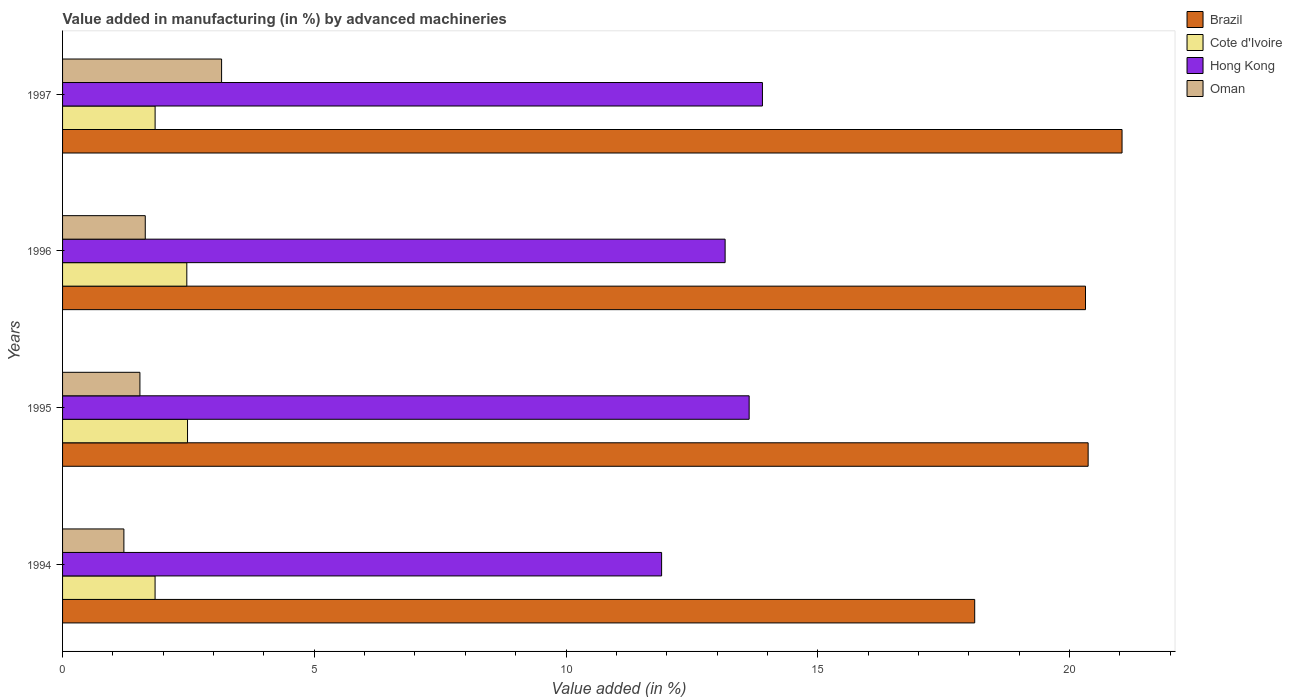How many different coloured bars are there?
Provide a short and direct response. 4. How many groups of bars are there?
Make the answer very short. 4. Are the number of bars on each tick of the Y-axis equal?
Your answer should be very brief. Yes. How many bars are there on the 3rd tick from the top?
Your answer should be compact. 4. In how many cases, is the number of bars for a given year not equal to the number of legend labels?
Provide a short and direct response. 0. What is the percentage of value added in manufacturing by advanced machineries in Oman in 1995?
Keep it short and to the point. 1.54. Across all years, what is the maximum percentage of value added in manufacturing by advanced machineries in Brazil?
Provide a succinct answer. 21.04. Across all years, what is the minimum percentage of value added in manufacturing by advanced machineries in Hong Kong?
Keep it short and to the point. 11.9. In which year was the percentage of value added in manufacturing by advanced machineries in Hong Kong maximum?
Your answer should be compact. 1997. What is the total percentage of value added in manufacturing by advanced machineries in Hong Kong in the graph?
Offer a very short reply. 52.6. What is the difference between the percentage of value added in manufacturing by advanced machineries in Brazil in 1995 and that in 1996?
Keep it short and to the point. 0.05. What is the difference between the percentage of value added in manufacturing by advanced machineries in Oman in 1996 and the percentage of value added in manufacturing by advanced machineries in Cote d'Ivoire in 1995?
Make the answer very short. -0.84. What is the average percentage of value added in manufacturing by advanced machineries in Brazil per year?
Give a very brief answer. 19.96. In the year 1995, what is the difference between the percentage of value added in manufacturing by advanced machineries in Hong Kong and percentage of value added in manufacturing by advanced machineries in Cote d'Ivoire?
Provide a short and direct response. 11.16. In how many years, is the percentage of value added in manufacturing by advanced machineries in Hong Kong greater than 21 %?
Provide a succinct answer. 0. What is the ratio of the percentage of value added in manufacturing by advanced machineries in Oman in 1994 to that in 1995?
Offer a terse response. 0.79. Is the percentage of value added in manufacturing by advanced machineries in Hong Kong in 1995 less than that in 1997?
Offer a very short reply. Yes. Is the difference between the percentage of value added in manufacturing by advanced machineries in Hong Kong in 1994 and 1997 greater than the difference between the percentage of value added in manufacturing by advanced machineries in Cote d'Ivoire in 1994 and 1997?
Make the answer very short. No. What is the difference between the highest and the second highest percentage of value added in manufacturing by advanced machineries in Hong Kong?
Your answer should be very brief. 0.26. What is the difference between the highest and the lowest percentage of value added in manufacturing by advanced machineries in Hong Kong?
Your response must be concise. 2. In how many years, is the percentage of value added in manufacturing by advanced machineries in Hong Kong greater than the average percentage of value added in manufacturing by advanced machineries in Hong Kong taken over all years?
Your answer should be very brief. 3. Is it the case that in every year, the sum of the percentage of value added in manufacturing by advanced machineries in Cote d'Ivoire and percentage of value added in manufacturing by advanced machineries in Brazil is greater than the sum of percentage of value added in manufacturing by advanced machineries in Oman and percentage of value added in manufacturing by advanced machineries in Hong Kong?
Ensure brevity in your answer.  Yes. What does the 1st bar from the top in 1997 represents?
Your answer should be very brief. Oman. What does the 2nd bar from the bottom in 1995 represents?
Offer a very short reply. Cote d'Ivoire. Is it the case that in every year, the sum of the percentage of value added in manufacturing by advanced machineries in Brazil and percentage of value added in manufacturing by advanced machineries in Cote d'Ivoire is greater than the percentage of value added in manufacturing by advanced machineries in Oman?
Keep it short and to the point. Yes. Are the values on the major ticks of X-axis written in scientific E-notation?
Your response must be concise. No. Does the graph contain any zero values?
Your response must be concise. No. Does the graph contain grids?
Keep it short and to the point. No. What is the title of the graph?
Give a very brief answer. Value added in manufacturing (in %) by advanced machineries. What is the label or title of the X-axis?
Make the answer very short. Value added (in %). What is the Value added (in %) of Brazil in 1994?
Offer a very short reply. 18.12. What is the Value added (in %) of Cote d'Ivoire in 1994?
Offer a very short reply. 1.84. What is the Value added (in %) in Hong Kong in 1994?
Provide a short and direct response. 11.9. What is the Value added (in %) of Oman in 1994?
Offer a terse response. 1.22. What is the Value added (in %) in Brazil in 1995?
Ensure brevity in your answer.  20.37. What is the Value added (in %) of Cote d'Ivoire in 1995?
Offer a terse response. 2.48. What is the Value added (in %) in Hong Kong in 1995?
Provide a short and direct response. 13.64. What is the Value added (in %) of Oman in 1995?
Keep it short and to the point. 1.54. What is the Value added (in %) in Brazil in 1996?
Offer a terse response. 20.32. What is the Value added (in %) of Cote d'Ivoire in 1996?
Ensure brevity in your answer.  2.47. What is the Value added (in %) in Hong Kong in 1996?
Provide a short and direct response. 13.16. What is the Value added (in %) in Oman in 1996?
Keep it short and to the point. 1.64. What is the Value added (in %) of Brazil in 1997?
Your response must be concise. 21.04. What is the Value added (in %) in Cote d'Ivoire in 1997?
Provide a short and direct response. 1.84. What is the Value added (in %) in Hong Kong in 1997?
Provide a succinct answer. 13.9. What is the Value added (in %) of Oman in 1997?
Offer a terse response. 3.16. Across all years, what is the maximum Value added (in %) in Brazil?
Your answer should be very brief. 21.04. Across all years, what is the maximum Value added (in %) of Cote d'Ivoire?
Provide a short and direct response. 2.48. Across all years, what is the maximum Value added (in %) in Hong Kong?
Ensure brevity in your answer.  13.9. Across all years, what is the maximum Value added (in %) in Oman?
Your response must be concise. 3.16. Across all years, what is the minimum Value added (in %) of Brazil?
Give a very brief answer. 18.12. Across all years, what is the minimum Value added (in %) of Cote d'Ivoire?
Make the answer very short. 1.84. Across all years, what is the minimum Value added (in %) in Hong Kong?
Provide a short and direct response. 11.9. Across all years, what is the minimum Value added (in %) of Oman?
Provide a short and direct response. 1.22. What is the total Value added (in %) in Brazil in the graph?
Give a very brief answer. 79.85. What is the total Value added (in %) of Cote d'Ivoire in the graph?
Your response must be concise. 8.63. What is the total Value added (in %) in Hong Kong in the graph?
Your answer should be very brief. 52.6. What is the total Value added (in %) in Oman in the graph?
Offer a very short reply. 7.56. What is the difference between the Value added (in %) of Brazil in 1994 and that in 1995?
Ensure brevity in your answer.  -2.25. What is the difference between the Value added (in %) in Cote d'Ivoire in 1994 and that in 1995?
Keep it short and to the point. -0.64. What is the difference between the Value added (in %) of Hong Kong in 1994 and that in 1995?
Your answer should be compact. -1.74. What is the difference between the Value added (in %) in Oman in 1994 and that in 1995?
Provide a succinct answer. -0.32. What is the difference between the Value added (in %) in Brazil in 1994 and that in 1996?
Ensure brevity in your answer.  -2.2. What is the difference between the Value added (in %) in Cote d'Ivoire in 1994 and that in 1996?
Provide a succinct answer. -0.63. What is the difference between the Value added (in %) of Hong Kong in 1994 and that in 1996?
Your answer should be compact. -1.26. What is the difference between the Value added (in %) in Oman in 1994 and that in 1996?
Provide a succinct answer. -0.42. What is the difference between the Value added (in %) in Brazil in 1994 and that in 1997?
Keep it short and to the point. -2.93. What is the difference between the Value added (in %) of Cote d'Ivoire in 1994 and that in 1997?
Keep it short and to the point. -0. What is the difference between the Value added (in %) in Hong Kong in 1994 and that in 1997?
Give a very brief answer. -2. What is the difference between the Value added (in %) of Oman in 1994 and that in 1997?
Your answer should be compact. -1.94. What is the difference between the Value added (in %) of Brazil in 1995 and that in 1996?
Offer a very short reply. 0.05. What is the difference between the Value added (in %) in Cote d'Ivoire in 1995 and that in 1996?
Offer a terse response. 0.01. What is the difference between the Value added (in %) in Hong Kong in 1995 and that in 1996?
Your answer should be very brief. 0.48. What is the difference between the Value added (in %) of Oman in 1995 and that in 1996?
Ensure brevity in your answer.  -0.11. What is the difference between the Value added (in %) of Brazil in 1995 and that in 1997?
Ensure brevity in your answer.  -0.67. What is the difference between the Value added (in %) in Cote d'Ivoire in 1995 and that in 1997?
Provide a short and direct response. 0.64. What is the difference between the Value added (in %) in Hong Kong in 1995 and that in 1997?
Provide a short and direct response. -0.26. What is the difference between the Value added (in %) of Oman in 1995 and that in 1997?
Your answer should be compact. -1.62. What is the difference between the Value added (in %) in Brazil in 1996 and that in 1997?
Make the answer very short. -0.73. What is the difference between the Value added (in %) in Cote d'Ivoire in 1996 and that in 1997?
Give a very brief answer. 0.63. What is the difference between the Value added (in %) of Hong Kong in 1996 and that in 1997?
Make the answer very short. -0.74. What is the difference between the Value added (in %) of Oman in 1996 and that in 1997?
Offer a terse response. -1.52. What is the difference between the Value added (in %) of Brazil in 1994 and the Value added (in %) of Cote d'Ivoire in 1995?
Make the answer very short. 15.64. What is the difference between the Value added (in %) of Brazil in 1994 and the Value added (in %) of Hong Kong in 1995?
Your response must be concise. 4.48. What is the difference between the Value added (in %) of Brazil in 1994 and the Value added (in %) of Oman in 1995?
Give a very brief answer. 16.58. What is the difference between the Value added (in %) of Cote d'Ivoire in 1994 and the Value added (in %) of Hong Kong in 1995?
Your answer should be very brief. -11.8. What is the difference between the Value added (in %) in Cote d'Ivoire in 1994 and the Value added (in %) in Oman in 1995?
Your answer should be very brief. 0.3. What is the difference between the Value added (in %) of Hong Kong in 1994 and the Value added (in %) of Oman in 1995?
Offer a very short reply. 10.36. What is the difference between the Value added (in %) of Brazil in 1994 and the Value added (in %) of Cote d'Ivoire in 1996?
Make the answer very short. 15.65. What is the difference between the Value added (in %) in Brazil in 1994 and the Value added (in %) in Hong Kong in 1996?
Keep it short and to the point. 4.96. What is the difference between the Value added (in %) of Brazil in 1994 and the Value added (in %) of Oman in 1996?
Give a very brief answer. 16.48. What is the difference between the Value added (in %) of Cote d'Ivoire in 1994 and the Value added (in %) of Hong Kong in 1996?
Provide a succinct answer. -11.32. What is the difference between the Value added (in %) in Cote d'Ivoire in 1994 and the Value added (in %) in Oman in 1996?
Your response must be concise. 0.19. What is the difference between the Value added (in %) of Hong Kong in 1994 and the Value added (in %) of Oman in 1996?
Offer a terse response. 10.26. What is the difference between the Value added (in %) in Brazil in 1994 and the Value added (in %) in Cote d'Ivoire in 1997?
Offer a very short reply. 16.28. What is the difference between the Value added (in %) in Brazil in 1994 and the Value added (in %) in Hong Kong in 1997?
Provide a short and direct response. 4.22. What is the difference between the Value added (in %) in Brazil in 1994 and the Value added (in %) in Oman in 1997?
Give a very brief answer. 14.96. What is the difference between the Value added (in %) in Cote d'Ivoire in 1994 and the Value added (in %) in Hong Kong in 1997?
Your answer should be very brief. -12.06. What is the difference between the Value added (in %) in Cote d'Ivoire in 1994 and the Value added (in %) in Oman in 1997?
Your response must be concise. -1.32. What is the difference between the Value added (in %) of Hong Kong in 1994 and the Value added (in %) of Oman in 1997?
Make the answer very short. 8.74. What is the difference between the Value added (in %) in Brazil in 1995 and the Value added (in %) in Cote d'Ivoire in 1996?
Offer a very short reply. 17.9. What is the difference between the Value added (in %) of Brazil in 1995 and the Value added (in %) of Hong Kong in 1996?
Give a very brief answer. 7.21. What is the difference between the Value added (in %) of Brazil in 1995 and the Value added (in %) of Oman in 1996?
Your response must be concise. 18.73. What is the difference between the Value added (in %) of Cote d'Ivoire in 1995 and the Value added (in %) of Hong Kong in 1996?
Your answer should be very brief. -10.68. What is the difference between the Value added (in %) of Cote d'Ivoire in 1995 and the Value added (in %) of Oman in 1996?
Your answer should be very brief. 0.84. What is the difference between the Value added (in %) in Hong Kong in 1995 and the Value added (in %) in Oman in 1996?
Provide a succinct answer. 12. What is the difference between the Value added (in %) in Brazil in 1995 and the Value added (in %) in Cote d'Ivoire in 1997?
Offer a very short reply. 18.53. What is the difference between the Value added (in %) in Brazil in 1995 and the Value added (in %) in Hong Kong in 1997?
Your answer should be very brief. 6.47. What is the difference between the Value added (in %) in Brazil in 1995 and the Value added (in %) in Oman in 1997?
Keep it short and to the point. 17.21. What is the difference between the Value added (in %) of Cote d'Ivoire in 1995 and the Value added (in %) of Hong Kong in 1997?
Make the answer very short. -11.42. What is the difference between the Value added (in %) of Cote d'Ivoire in 1995 and the Value added (in %) of Oman in 1997?
Give a very brief answer. -0.68. What is the difference between the Value added (in %) of Hong Kong in 1995 and the Value added (in %) of Oman in 1997?
Provide a short and direct response. 10.48. What is the difference between the Value added (in %) of Brazil in 1996 and the Value added (in %) of Cote d'Ivoire in 1997?
Make the answer very short. 18.48. What is the difference between the Value added (in %) of Brazil in 1996 and the Value added (in %) of Hong Kong in 1997?
Your answer should be very brief. 6.42. What is the difference between the Value added (in %) in Brazil in 1996 and the Value added (in %) in Oman in 1997?
Ensure brevity in your answer.  17.16. What is the difference between the Value added (in %) of Cote d'Ivoire in 1996 and the Value added (in %) of Hong Kong in 1997?
Make the answer very short. -11.43. What is the difference between the Value added (in %) in Cote d'Ivoire in 1996 and the Value added (in %) in Oman in 1997?
Give a very brief answer. -0.69. What is the difference between the Value added (in %) of Hong Kong in 1996 and the Value added (in %) of Oman in 1997?
Give a very brief answer. 10. What is the average Value added (in %) of Brazil per year?
Provide a succinct answer. 19.96. What is the average Value added (in %) of Cote d'Ivoire per year?
Provide a succinct answer. 2.16. What is the average Value added (in %) in Hong Kong per year?
Your answer should be very brief. 13.15. What is the average Value added (in %) of Oman per year?
Offer a terse response. 1.89. In the year 1994, what is the difference between the Value added (in %) in Brazil and Value added (in %) in Cote d'Ivoire?
Ensure brevity in your answer.  16.28. In the year 1994, what is the difference between the Value added (in %) in Brazil and Value added (in %) in Hong Kong?
Make the answer very short. 6.22. In the year 1994, what is the difference between the Value added (in %) of Brazil and Value added (in %) of Oman?
Offer a terse response. 16.9. In the year 1994, what is the difference between the Value added (in %) in Cote d'Ivoire and Value added (in %) in Hong Kong?
Ensure brevity in your answer.  -10.06. In the year 1994, what is the difference between the Value added (in %) of Cote d'Ivoire and Value added (in %) of Oman?
Give a very brief answer. 0.62. In the year 1994, what is the difference between the Value added (in %) in Hong Kong and Value added (in %) in Oman?
Your answer should be very brief. 10.68. In the year 1995, what is the difference between the Value added (in %) in Brazil and Value added (in %) in Cote d'Ivoire?
Your answer should be compact. 17.89. In the year 1995, what is the difference between the Value added (in %) of Brazil and Value added (in %) of Hong Kong?
Give a very brief answer. 6.73. In the year 1995, what is the difference between the Value added (in %) of Brazil and Value added (in %) of Oman?
Provide a short and direct response. 18.83. In the year 1995, what is the difference between the Value added (in %) in Cote d'Ivoire and Value added (in %) in Hong Kong?
Ensure brevity in your answer.  -11.16. In the year 1995, what is the difference between the Value added (in %) in Cote d'Ivoire and Value added (in %) in Oman?
Make the answer very short. 0.95. In the year 1995, what is the difference between the Value added (in %) of Hong Kong and Value added (in %) of Oman?
Offer a very short reply. 12.1. In the year 1996, what is the difference between the Value added (in %) in Brazil and Value added (in %) in Cote d'Ivoire?
Ensure brevity in your answer.  17.85. In the year 1996, what is the difference between the Value added (in %) of Brazil and Value added (in %) of Hong Kong?
Offer a very short reply. 7.16. In the year 1996, what is the difference between the Value added (in %) in Brazil and Value added (in %) in Oman?
Offer a terse response. 18.68. In the year 1996, what is the difference between the Value added (in %) of Cote d'Ivoire and Value added (in %) of Hong Kong?
Your response must be concise. -10.69. In the year 1996, what is the difference between the Value added (in %) of Cote d'Ivoire and Value added (in %) of Oman?
Your answer should be compact. 0.83. In the year 1996, what is the difference between the Value added (in %) of Hong Kong and Value added (in %) of Oman?
Provide a succinct answer. 11.52. In the year 1997, what is the difference between the Value added (in %) of Brazil and Value added (in %) of Cote d'Ivoire?
Offer a very short reply. 19.21. In the year 1997, what is the difference between the Value added (in %) of Brazil and Value added (in %) of Hong Kong?
Offer a terse response. 7.14. In the year 1997, what is the difference between the Value added (in %) of Brazil and Value added (in %) of Oman?
Make the answer very short. 17.89. In the year 1997, what is the difference between the Value added (in %) in Cote d'Ivoire and Value added (in %) in Hong Kong?
Your answer should be compact. -12.06. In the year 1997, what is the difference between the Value added (in %) in Cote d'Ivoire and Value added (in %) in Oman?
Your response must be concise. -1.32. In the year 1997, what is the difference between the Value added (in %) in Hong Kong and Value added (in %) in Oman?
Provide a short and direct response. 10.74. What is the ratio of the Value added (in %) in Brazil in 1994 to that in 1995?
Ensure brevity in your answer.  0.89. What is the ratio of the Value added (in %) of Cote d'Ivoire in 1994 to that in 1995?
Offer a terse response. 0.74. What is the ratio of the Value added (in %) of Hong Kong in 1994 to that in 1995?
Offer a terse response. 0.87. What is the ratio of the Value added (in %) in Oman in 1994 to that in 1995?
Provide a short and direct response. 0.79. What is the ratio of the Value added (in %) of Brazil in 1994 to that in 1996?
Offer a terse response. 0.89. What is the ratio of the Value added (in %) in Cote d'Ivoire in 1994 to that in 1996?
Your answer should be compact. 0.74. What is the ratio of the Value added (in %) of Hong Kong in 1994 to that in 1996?
Provide a short and direct response. 0.9. What is the ratio of the Value added (in %) in Oman in 1994 to that in 1996?
Ensure brevity in your answer.  0.74. What is the ratio of the Value added (in %) of Brazil in 1994 to that in 1997?
Provide a succinct answer. 0.86. What is the ratio of the Value added (in %) of Hong Kong in 1994 to that in 1997?
Offer a very short reply. 0.86. What is the ratio of the Value added (in %) of Oman in 1994 to that in 1997?
Provide a short and direct response. 0.39. What is the ratio of the Value added (in %) in Brazil in 1995 to that in 1996?
Provide a succinct answer. 1. What is the ratio of the Value added (in %) in Cote d'Ivoire in 1995 to that in 1996?
Make the answer very short. 1.01. What is the ratio of the Value added (in %) in Hong Kong in 1995 to that in 1996?
Provide a succinct answer. 1.04. What is the ratio of the Value added (in %) of Oman in 1995 to that in 1996?
Ensure brevity in your answer.  0.94. What is the ratio of the Value added (in %) in Cote d'Ivoire in 1995 to that in 1997?
Your response must be concise. 1.35. What is the ratio of the Value added (in %) of Hong Kong in 1995 to that in 1997?
Provide a succinct answer. 0.98. What is the ratio of the Value added (in %) of Oman in 1995 to that in 1997?
Keep it short and to the point. 0.49. What is the ratio of the Value added (in %) in Brazil in 1996 to that in 1997?
Offer a very short reply. 0.97. What is the ratio of the Value added (in %) in Cote d'Ivoire in 1996 to that in 1997?
Keep it short and to the point. 1.34. What is the ratio of the Value added (in %) in Hong Kong in 1996 to that in 1997?
Give a very brief answer. 0.95. What is the ratio of the Value added (in %) of Oman in 1996 to that in 1997?
Your response must be concise. 0.52. What is the difference between the highest and the second highest Value added (in %) of Brazil?
Your response must be concise. 0.67. What is the difference between the highest and the second highest Value added (in %) in Cote d'Ivoire?
Give a very brief answer. 0.01. What is the difference between the highest and the second highest Value added (in %) of Hong Kong?
Provide a succinct answer. 0.26. What is the difference between the highest and the second highest Value added (in %) in Oman?
Offer a terse response. 1.52. What is the difference between the highest and the lowest Value added (in %) of Brazil?
Give a very brief answer. 2.93. What is the difference between the highest and the lowest Value added (in %) in Cote d'Ivoire?
Your answer should be compact. 0.64. What is the difference between the highest and the lowest Value added (in %) in Hong Kong?
Make the answer very short. 2. What is the difference between the highest and the lowest Value added (in %) in Oman?
Your response must be concise. 1.94. 